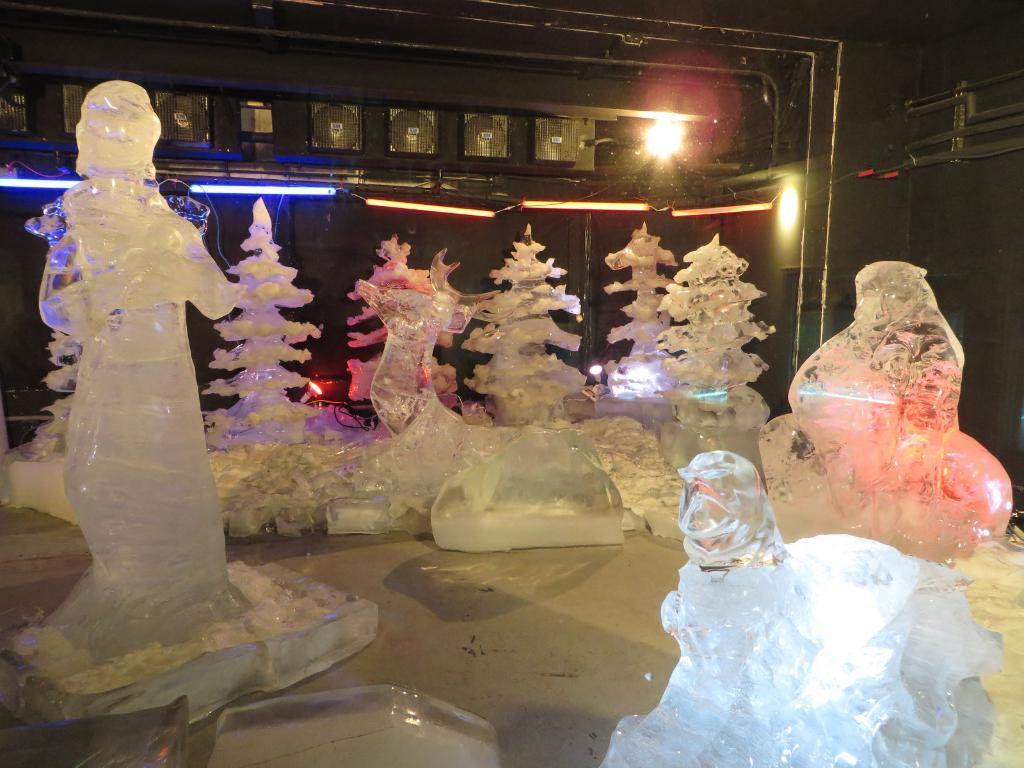Could you give a brief overview of what you see in this image? We can see ice sculptures on the surface. In the background we can see lights and wall. 